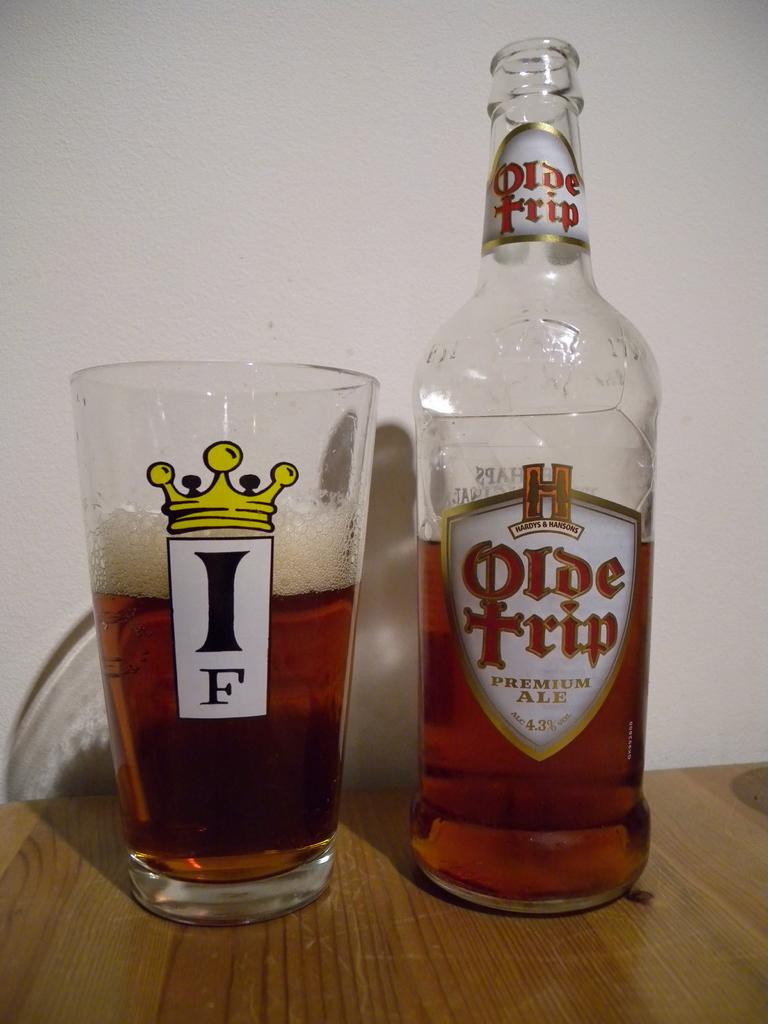Provide a one-sentence caption for the provided image. a bottle of Olde tripe Premium Ale and a glass of it next to it. 